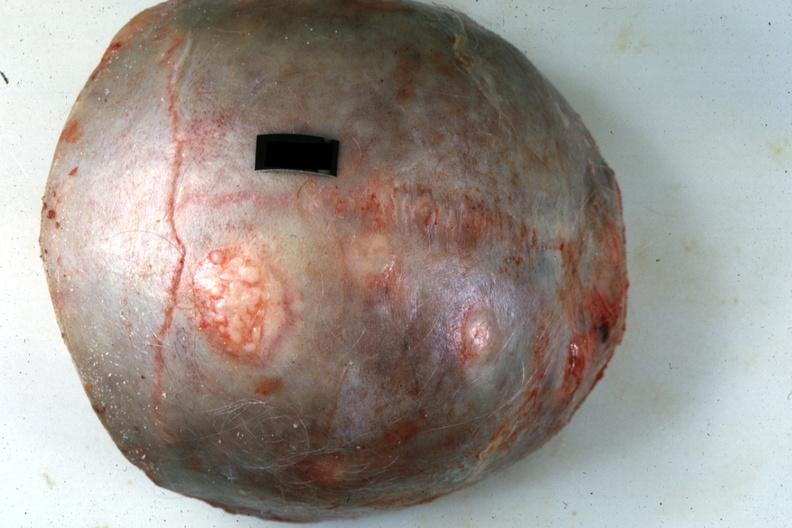what is present?
Answer the question using a single word or phrase. Metastatic pancreas carcinoma 